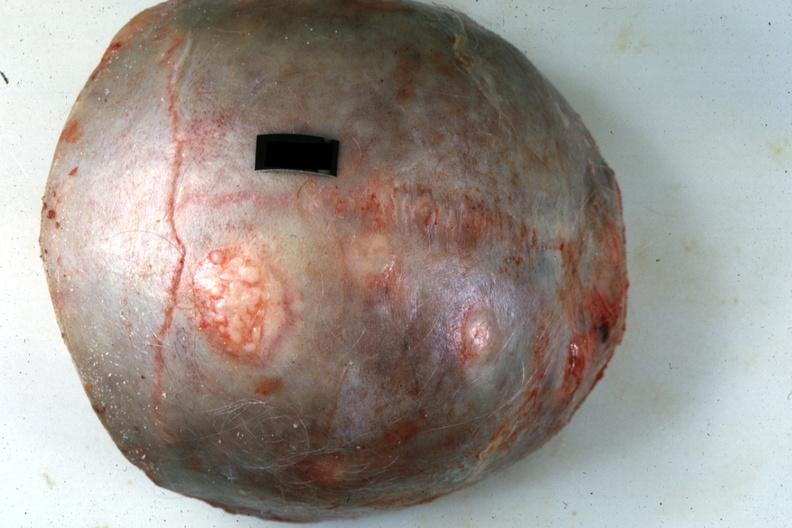what is present?
Answer the question using a single word or phrase. Metastatic pancreas carcinoma 